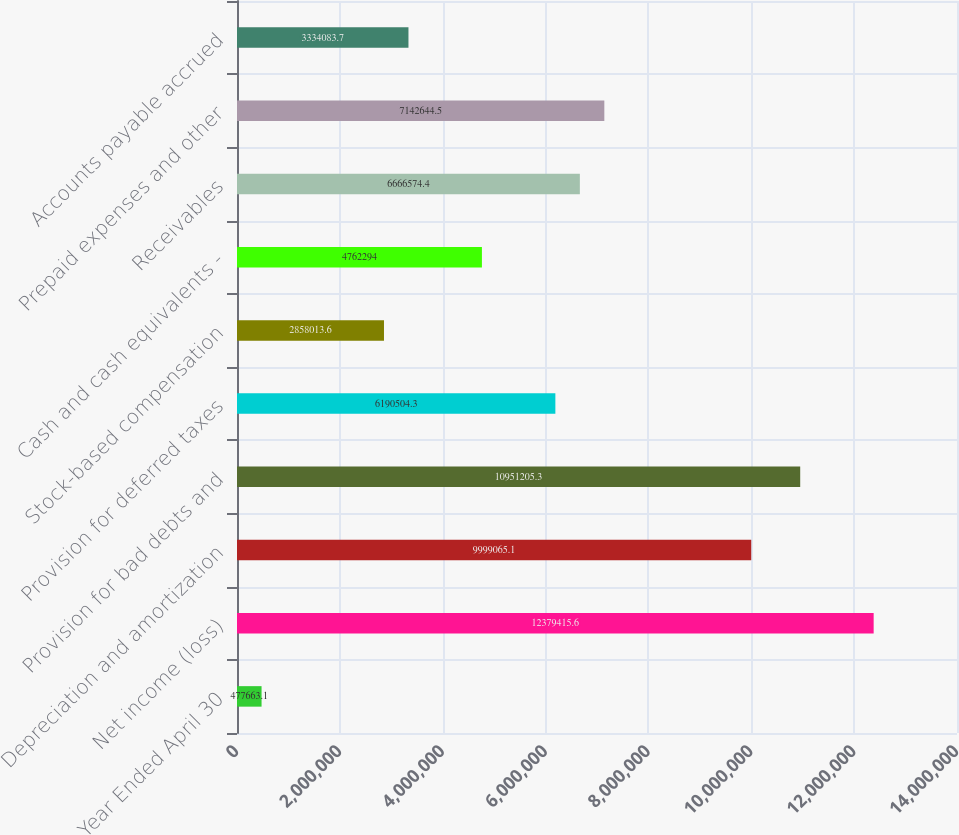Convert chart. <chart><loc_0><loc_0><loc_500><loc_500><bar_chart><fcel>Year Ended April 30<fcel>Net income (loss)<fcel>Depreciation and amortization<fcel>Provision for bad debts and<fcel>Provision for deferred taxes<fcel>Stock-based compensation<fcel>Cash and cash equivalents -<fcel>Receivables<fcel>Prepaid expenses and other<fcel>Accounts payable accrued<nl><fcel>477663<fcel>1.23794e+07<fcel>9.99907e+06<fcel>1.09512e+07<fcel>6.1905e+06<fcel>2.85801e+06<fcel>4.76229e+06<fcel>6.66657e+06<fcel>7.14264e+06<fcel>3.33408e+06<nl></chart> 